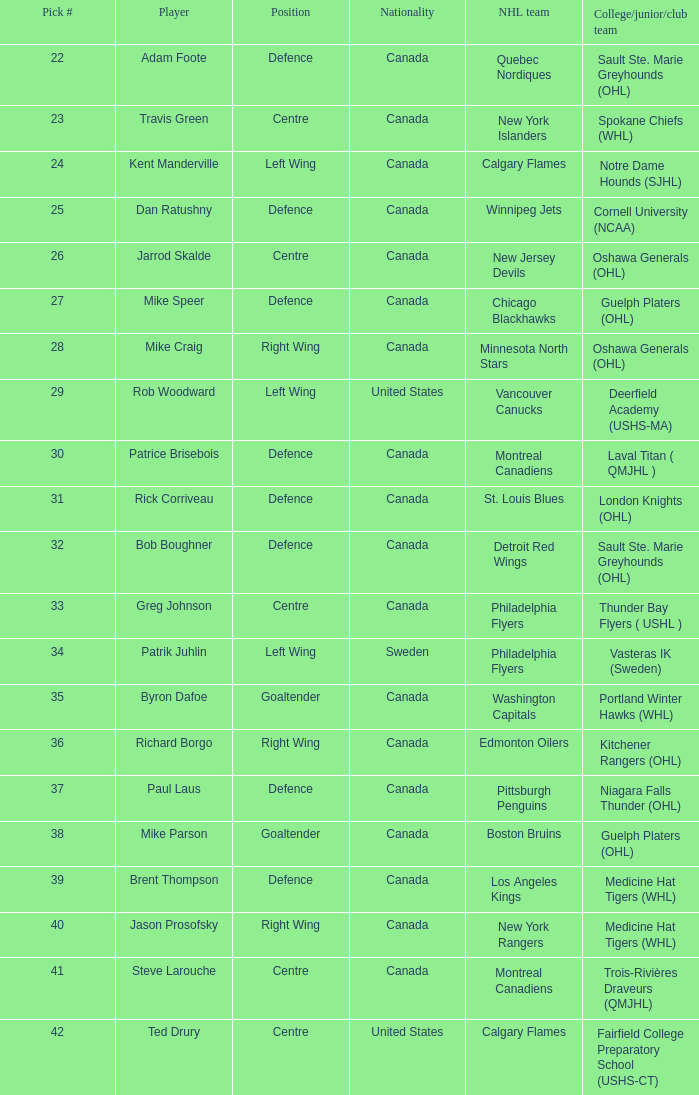What player came from Cornell University (NCAA)? Dan Ratushny. Could you help me parse every detail presented in this table? {'header': ['Pick #', 'Player', 'Position', 'Nationality', 'NHL team', 'College/junior/club team'], 'rows': [['22', 'Adam Foote', 'Defence', 'Canada', 'Quebec Nordiques', 'Sault Ste. Marie Greyhounds (OHL)'], ['23', 'Travis Green', 'Centre', 'Canada', 'New York Islanders', 'Spokane Chiefs (WHL)'], ['24', 'Kent Manderville', 'Left Wing', 'Canada', 'Calgary Flames', 'Notre Dame Hounds (SJHL)'], ['25', 'Dan Ratushny', 'Defence', 'Canada', 'Winnipeg Jets', 'Cornell University (NCAA)'], ['26', 'Jarrod Skalde', 'Centre', 'Canada', 'New Jersey Devils', 'Oshawa Generals (OHL)'], ['27', 'Mike Speer', 'Defence', 'Canada', 'Chicago Blackhawks', 'Guelph Platers (OHL)'], ['28', 'Mike Craig', 'Right Wing', 'Canada', 'Minnesota North Stars', 'Oshawa Generals (OHL)'], ['29', 'Rob Woodward', 'Left Wing', 'United States', 'Vancouver Canucks', 'Deerfield Academy (USHS-MA)'], ['30', 'Patrice Brisebois', 'Defence', 'Canada', 'Montreal Canadiens', 'Laval Titan ( QMJHL )'], ['31', 'Rick Corriveau', 'Defence', 'Canada', 'St. Louis Blues', 'London Knights (OHL)'], ['32', 'Bob Boughner', 'Defence', 'Canada', 'Detroit Red Wings', 'Sault Ste. Marie Greyhounds (OHL)'], ['33', 'Greg Johnson', 'Centre', 'Canada', 'Philadelphia Flyers', 'Thunder Bay Flyers ( USHL )'], ['34', 'Patrik Juhlin', 'Left Wing', 'Sweden', 'Philadelphia Flyers', 'Vasteras IK (Sweden)'], ['35', 'Byron Dafoe', 'Goaltender', 'Canada', 'Washington Capitals', 'Portland Winter Hawks (WHL)'], ['36', 'Richard Borgo', 'Right Wing', 'Canada', 'Edmonton Oilers', 'Kitchener Rangers (OHL)'], ['37', 'Paul Laus', 'Defence', 'Canada', 'Pittsburgh Penguins', 'Niagara Falls Thunder (OHL)'], ['38', 'Mike Parson', 'Goaltender', 'Canada', 'Boston Bruins', 'Guelph Platers (OHL)'], ['39', 'Brent Thompson', 'Defence', 'Canada', 'Los Angeles Kings', 'Medicine Hat Tigers (WHL)'], ['40', 'Jason Prosofsky', 'Right Wing', 'Canada', 'New York Rangers', 'Medicine Hat Tigers (WHL)'], ['41', 'Steve Larouche', 'Centre', 'Canada', 'Montreal Canadiens', 'Trois-Rivières Draveurs (QMJHL)'], ['42', 'Ted Drury', 'Centre', 'United States', 'Calgary Flames', 'Fairfield College Preparatory School (USHS-CT)']]} 